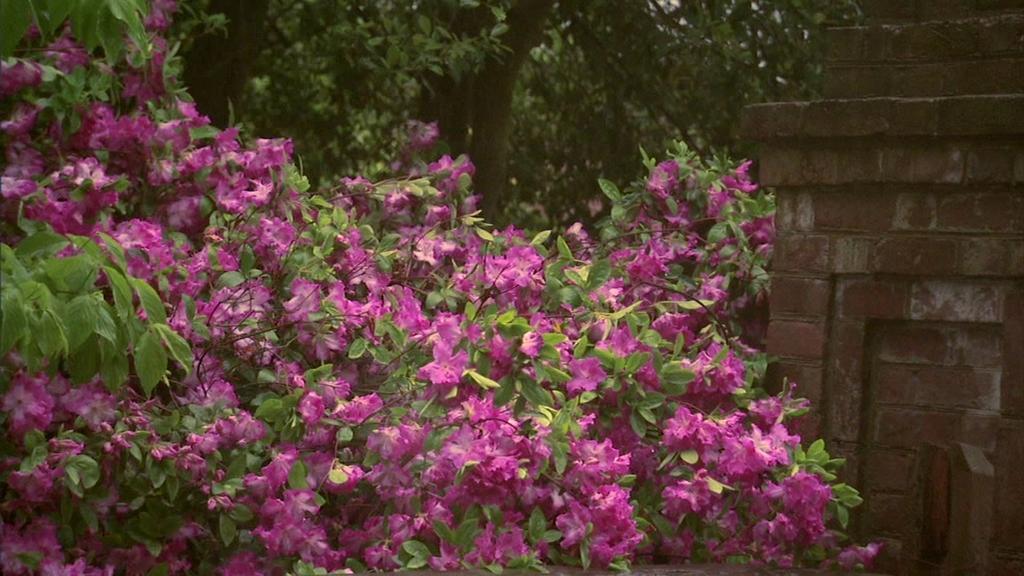Please provide a concise description of this image. In this image we can see some plants with flowers on it, there are some trees and also we can see the wall. 